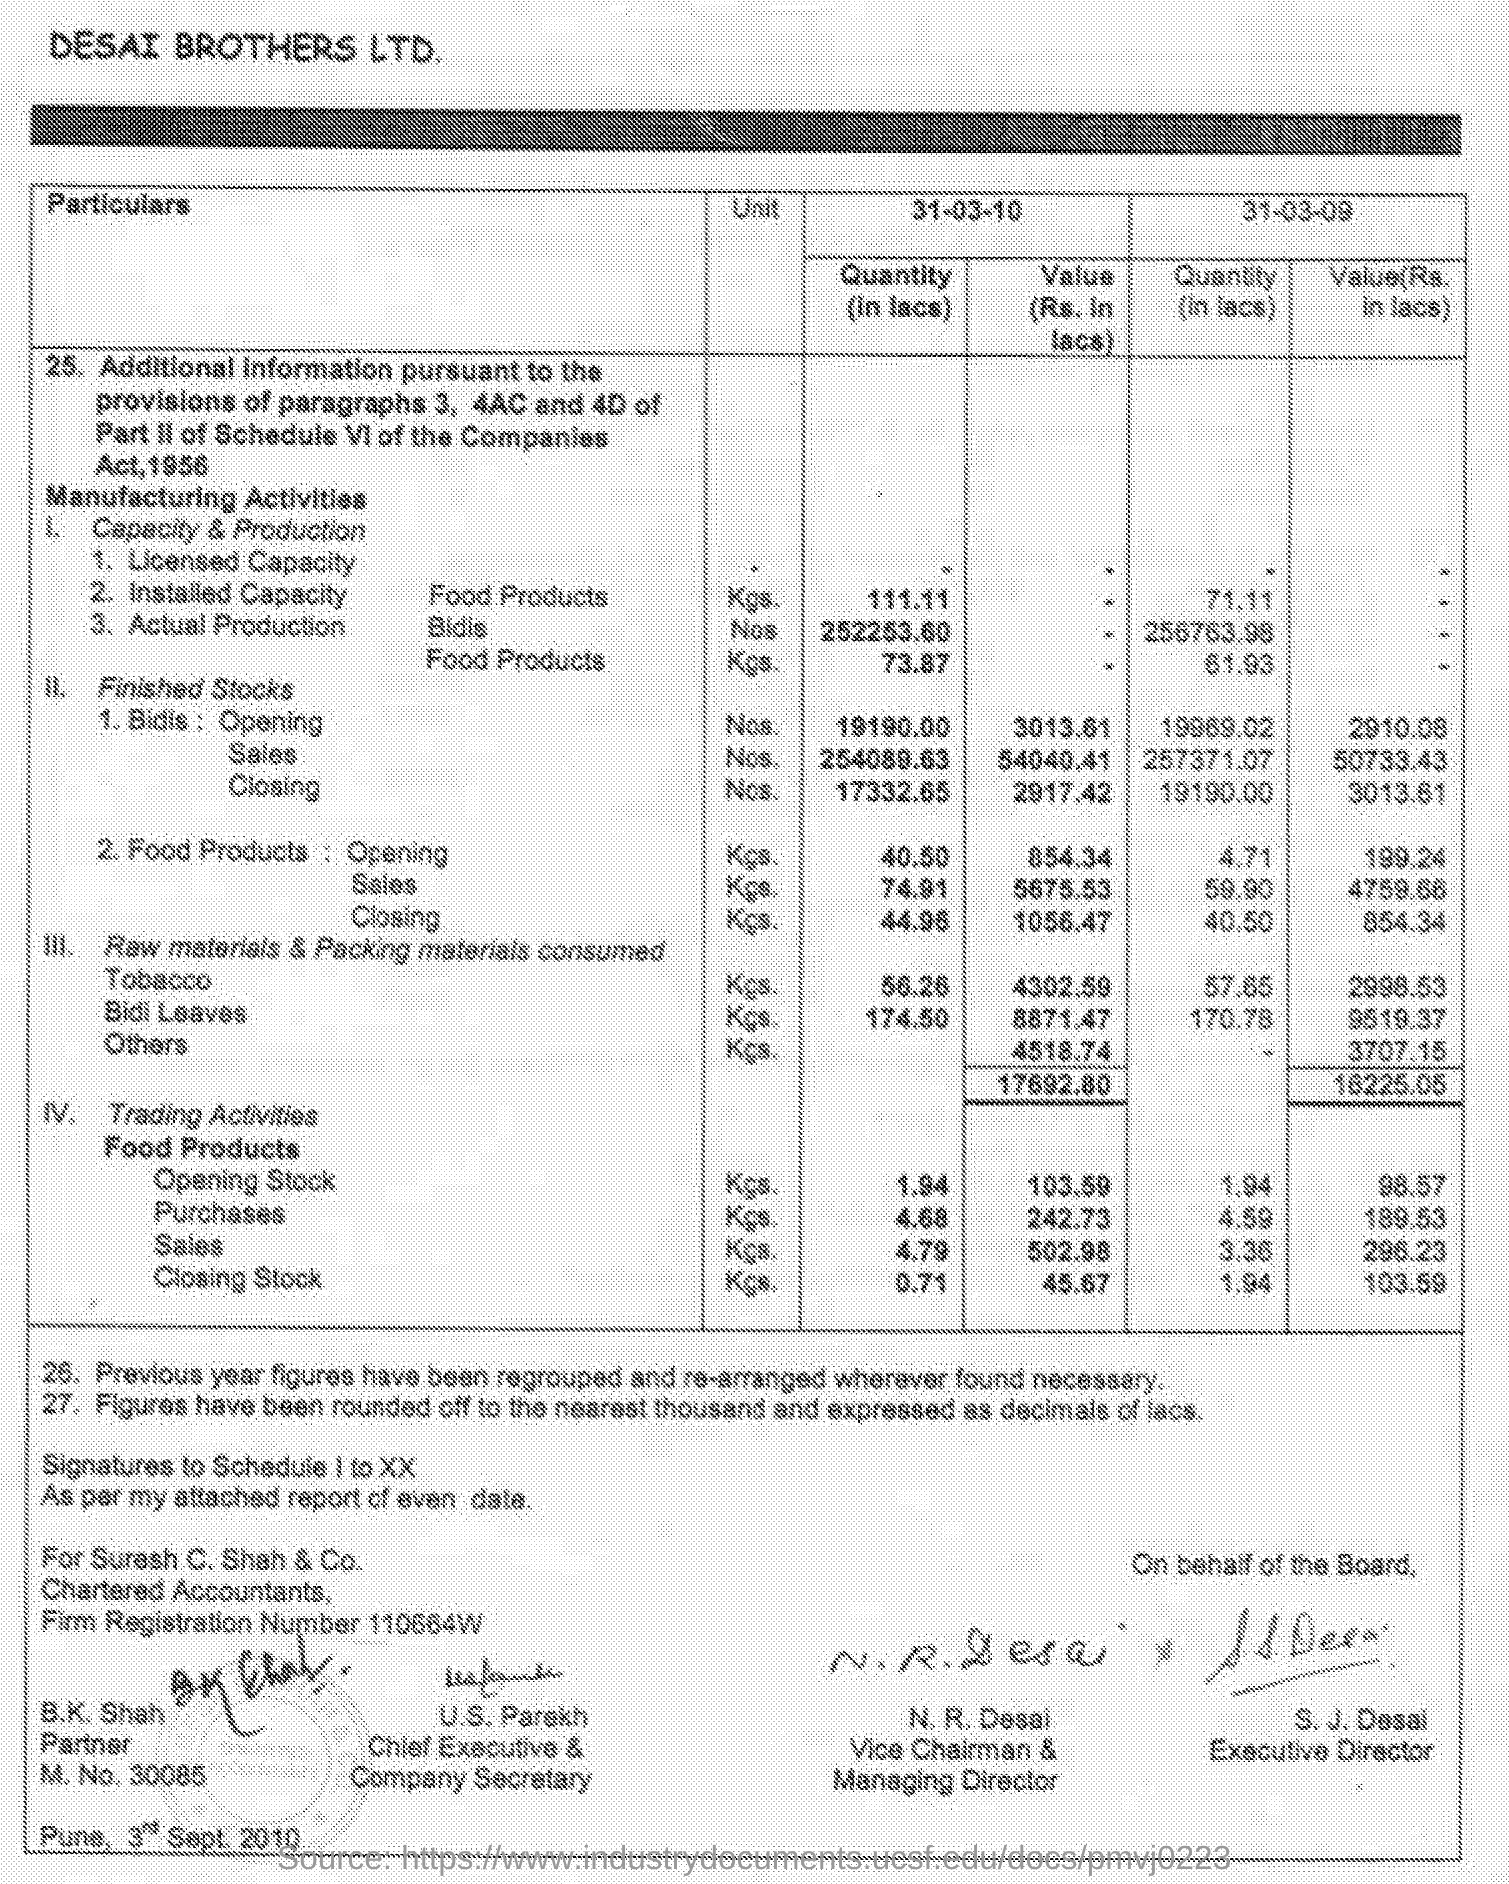Outline some significant characteristics in this image. The weight of food products is specified in the document. The name of the city located at the bottom left corner of the given page is Pune. The number M.NO. 30085 was mentioned. The heading given to the first column of the table is "Particulars. S.J. Desai is designated as the Executive Director. 